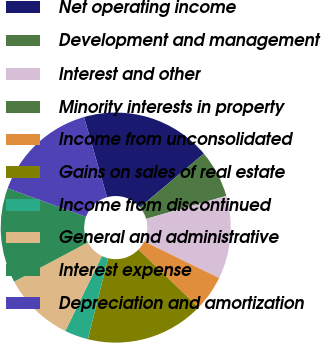<chart> <loc_0><loc_0><loc_500><loc_500><pie_chart><fcel>Net operating income<fcel>Development and management<fcel>Interest and other<fcel>Minority interests in property<fcel>Income from unconsolidated<fcel>Gains on sales of real estate<fcel>Income from discontinued<fcel>General and administrative<fcel>Interest expense<fcel>Depreciation and amortization<nl><fcel>18.33%<fcel>6.67%<fcel>11.67%<fcel>0.0%<fcel>5.0%<fcel>16.67%<fcel>3.33%<fcel>10.0%<fcel>13.33%<fcel>15.0%<nl></chart> 